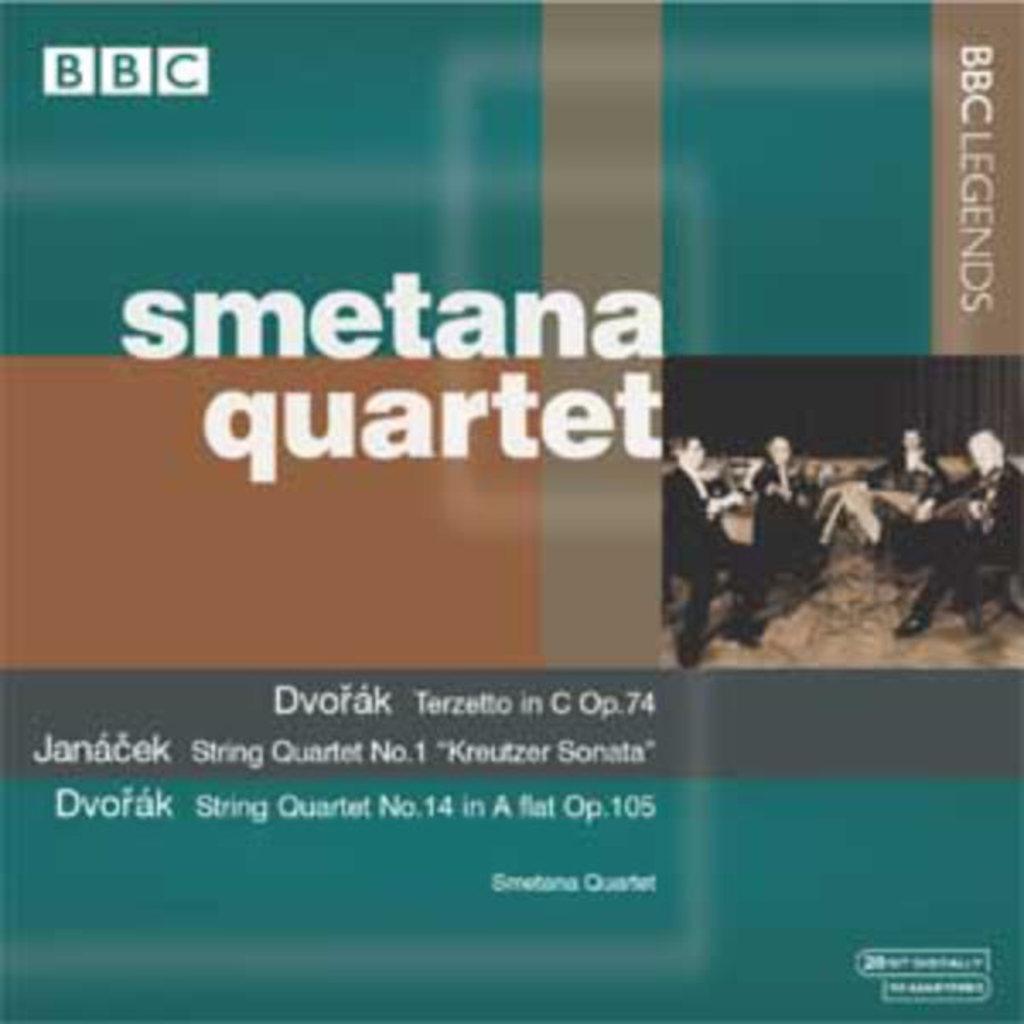Can you describe this image briefly? In this picture there is a poster. On the poster there are group of people sitting and playing musical instruments and there is text. 